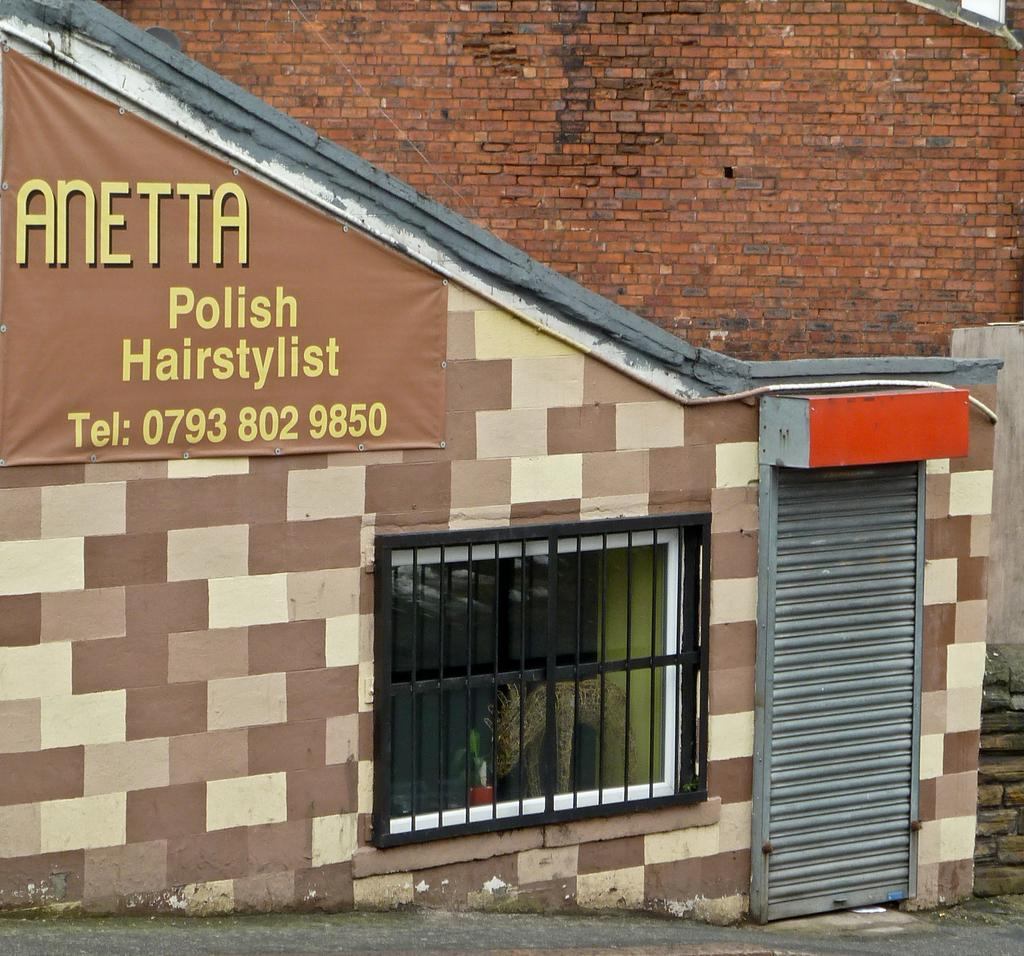What type of structures can be seen in the image? There are sheds in the image. What is placed on a wall in the image? There is a board placed on a wall in the image. What can be seen at the bottom of the image? There is a road at the bottom of the image. How much blood can be seen on the road in the image? There is no blood visible on the road in the image. 